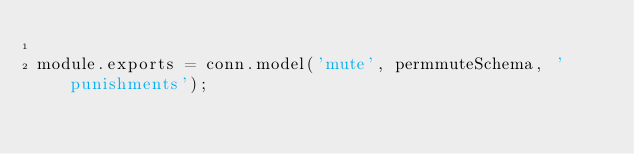Convert code to text. <code><loc_0><loc_0><loc_500><loc_500><_JavaScript_>
module.exports = conn.model('mute', permmuteSchema, 'punishments');
</code> 